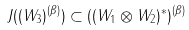Convert formula to latex. <formula><loc_0><loc_0><loc_500><loc_500>J ( ( W _ { 3 } ) ^ { ( \beta ) } ) \subset ( ( W _ { 1 } \otimes W _ { 2 } ) ^ { * } ) ^ { ( \beta ) }</formula> 